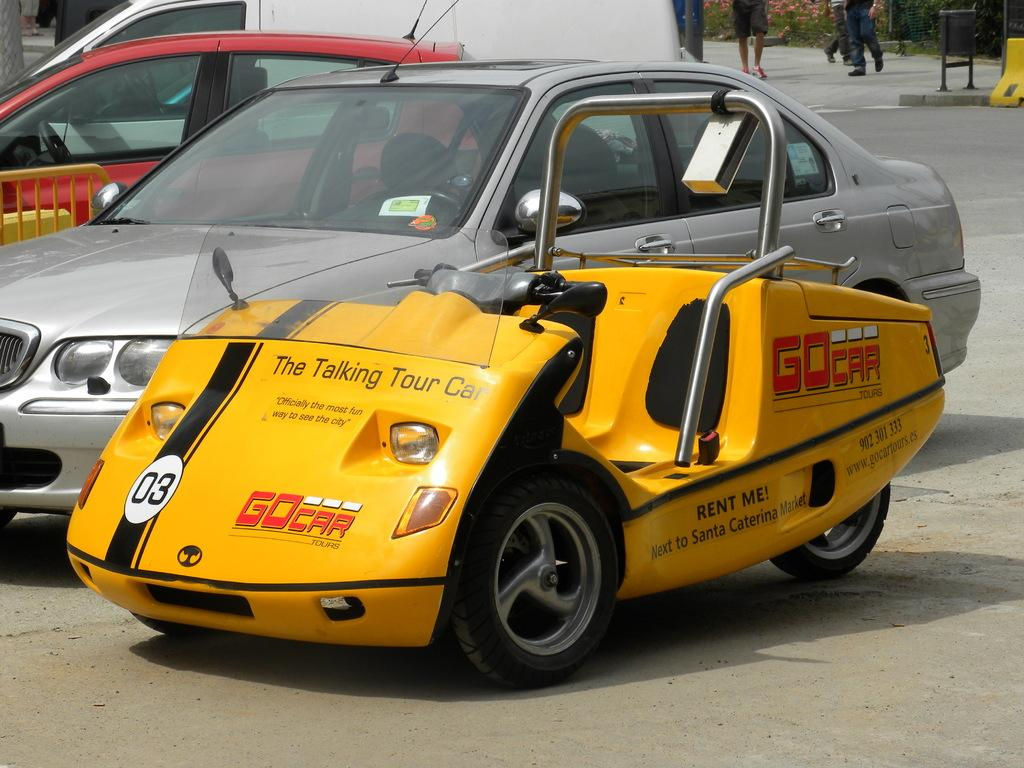<image>
Offer a succinct explanation of the picture presented. the word GoCar on the front of a car 